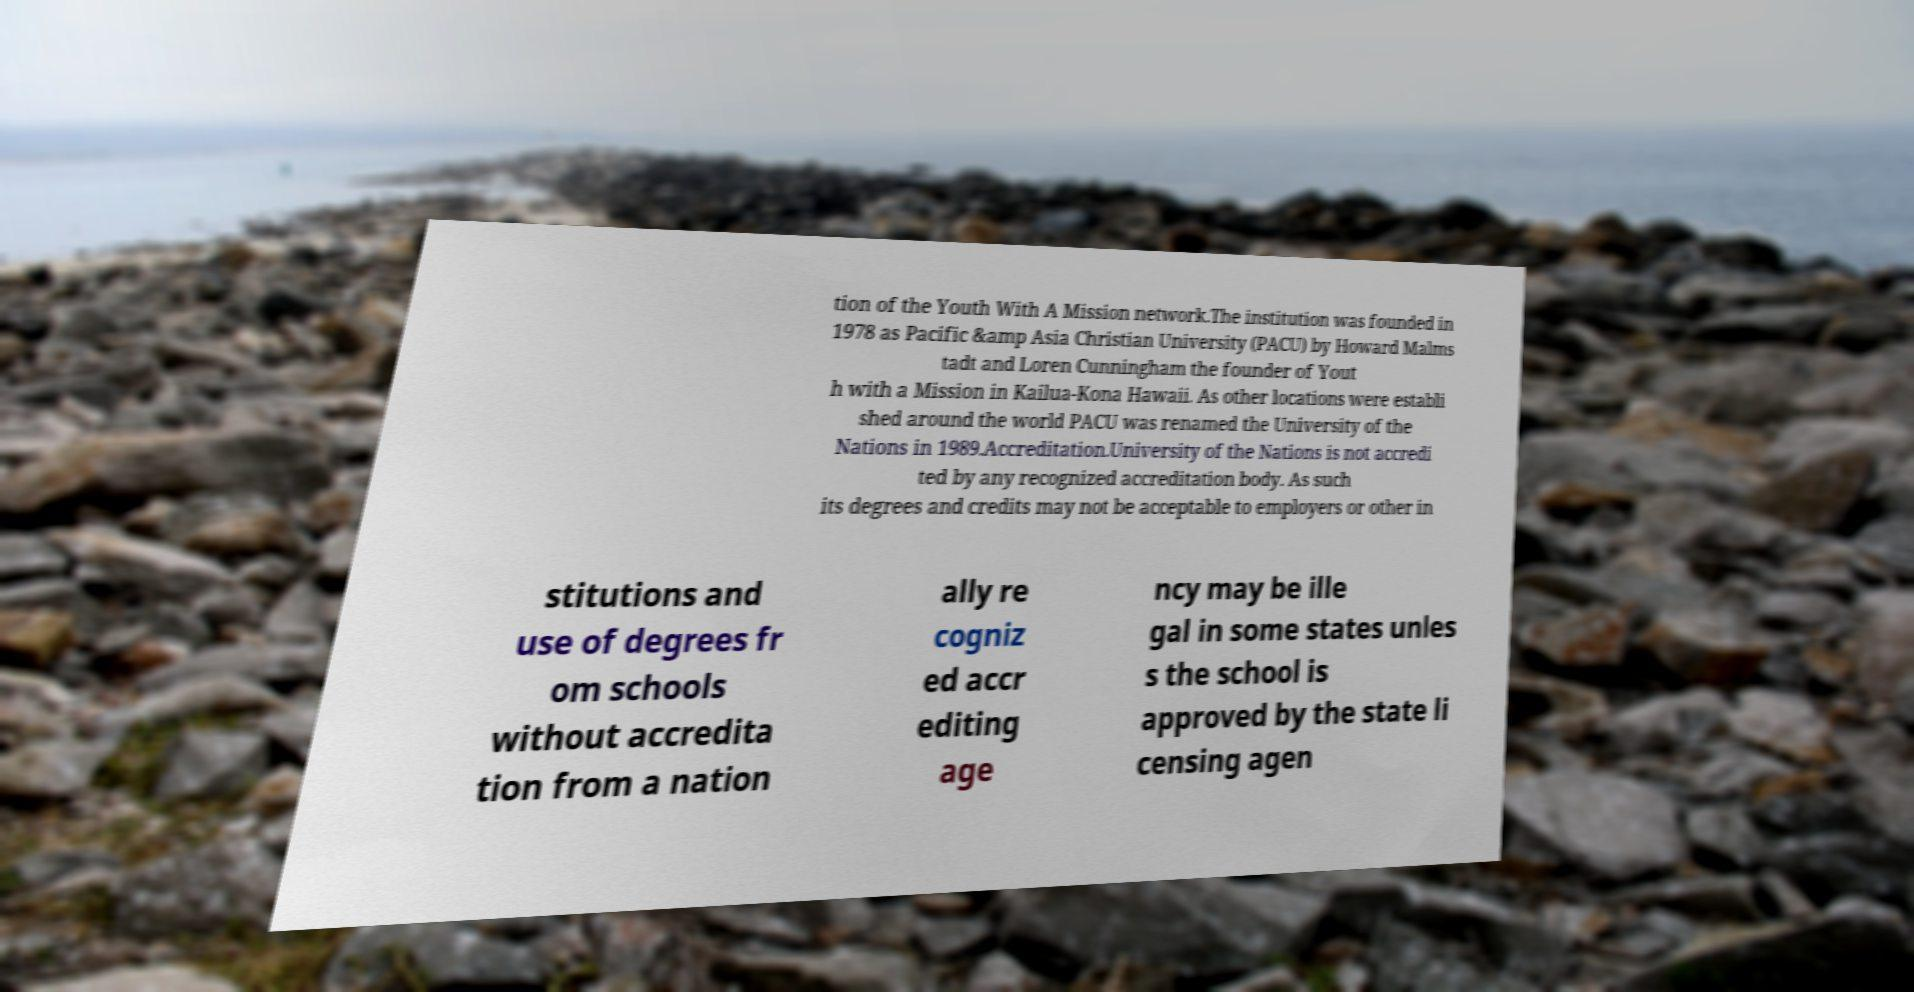Can you accurately transcribe the text from the provided image for me? tion of the Youth With A Mission network.The institution was founded in 1978 as Pacific &amp Asia Christian University (PACU) by Howard Malms tadt and Loren Cunningham the founder of Yout h with a Mission in Kailua-Kona Hawaii. As other locations were establi shed around the world PACU was renamed the University of the Nations in 1989.Accreditation.University of the Nations is not accredi ted by any recognized accreditation body. As such its degrees and credits may not be acceptable to employers or other in stitutions and use of degrees fr om schools without accredita tion from a nation ally re cogniz ed accr editing age ncy may be ille gal in some states unles s the school is approved by the state li censing agen 